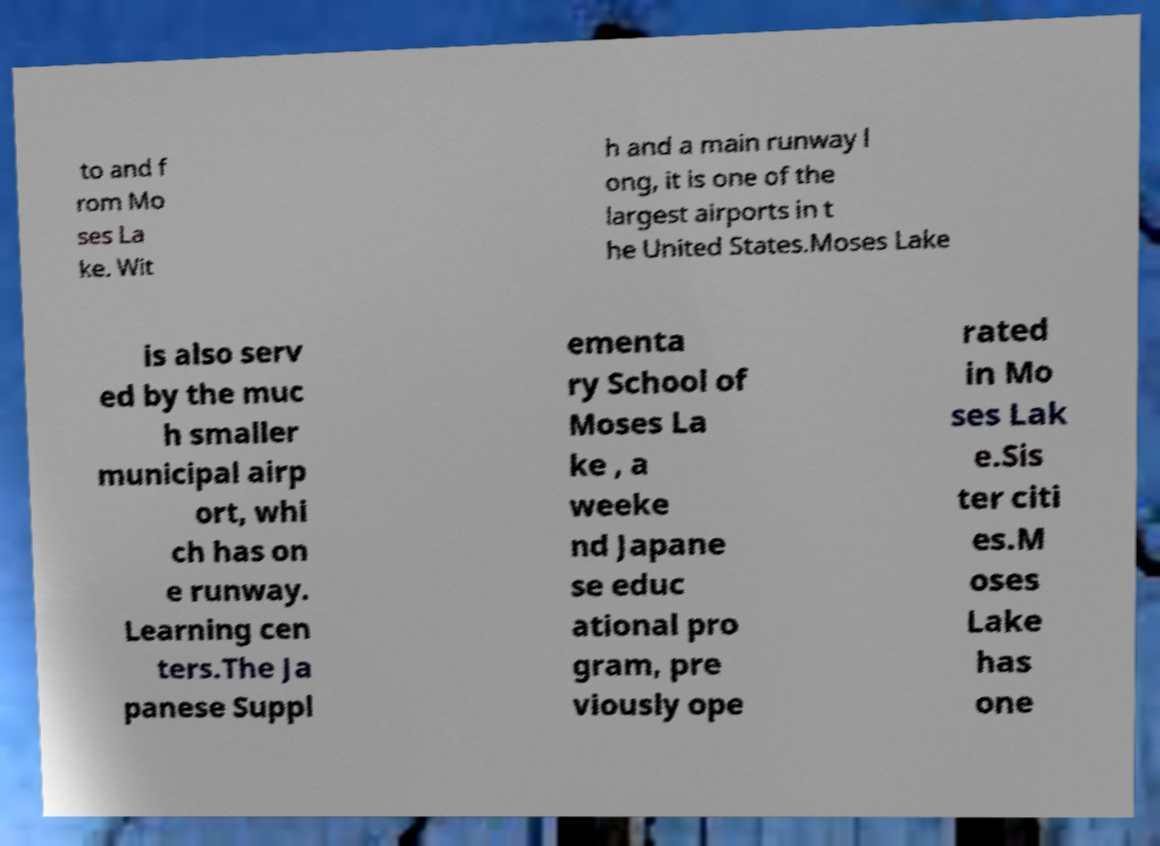Please read and relay the text visible in this image. What does it say? to and f rom Mo ses La ke. Wit h and a main runway l ong, it is one of the largest airports in t he United States.Moses Lake is also serv ed by the muc h smaller municipal airp ort, whi ch has on e runway. Learning cen ters.The Ja panese Suppl ementa ry School of Moses La ke , a weeke nd Japane se educ ational pro gram, pre viously ope rated in Mo ses Lak e.Sis ter citi es.M oses Lake has one 